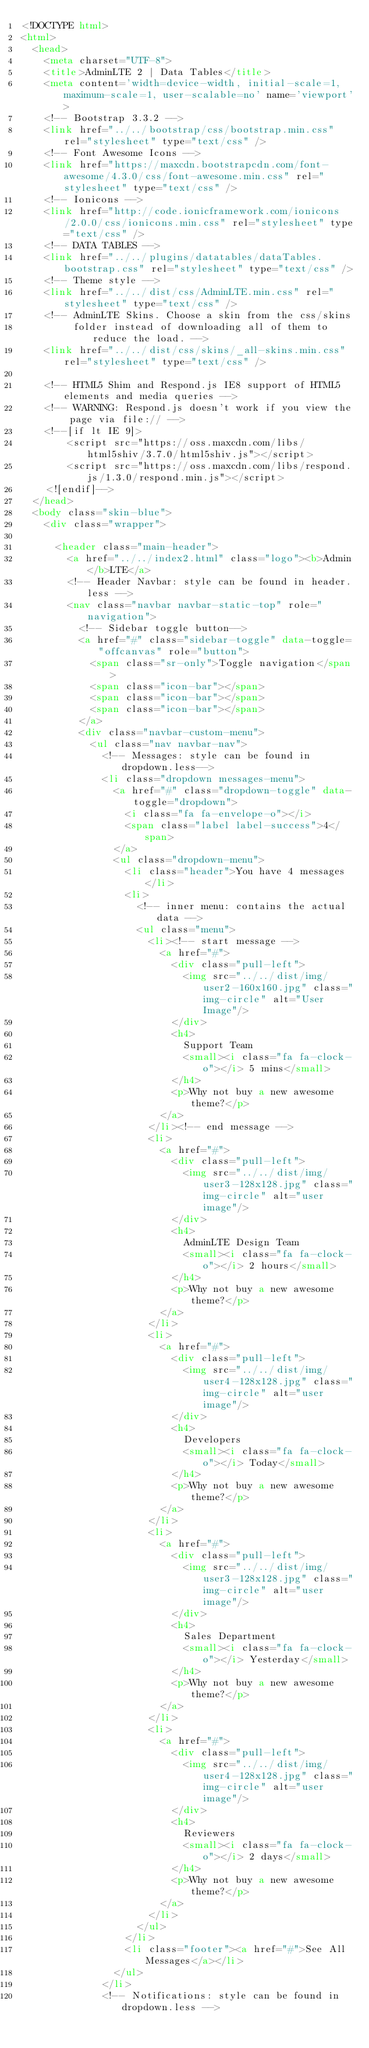Convert code to text. <code><loc_0><loc_0><loc_500><loc_500><_HTML_><!DOCTYPE html>
<html>
  <head>
    <meta charset="UTF-8">
    <title>AdminLTE 2 | Data Tables</title>
    <meta content='width=device-width, initial-scale=1, maximum-scale=1, user-scalable=no' name='viewport'>
    <!-- Bootstrap 3.3.2 -->
    <link href="../../bootstrap/css/bootstrap.min.css" rel="stylesheet" type="text/css" />
    <!-- Font Awesome Icons -->
    <link href="https://maxcdn.bootstrapcdn.com/font-awesome/4.3.0/css/font-awesome.min.css" rel="stylesheet" type="text/css" />
    <!-- Ionicons -->
    <link href="http://code.ionicframework.com/ionicons/2.0.0/css/ionicons.min.css" rel="stylesheet" type="text/css" />
    <!-- DATA TABLES -->
    <link href="../../plugins/datatables/dataTables.bootstrap.css" rel="stylesheet" type="text/css" />
    <!-- Theme style -->
    <link href="../../dist/css/AdminLTE.min.css" rel="stylesheet" type="text/css" />
    <!-- AdminLTE Skins. Choose a skin from the css/skins 
         folder instead of downloading all of them to reduce the load. -->
    <link href="../../dist/css/skins/_all-skins.min.css" rel="stylesheet" type="text/css" />

    <!-- HTML5 Shim and Respond.js IE8 support of HTML5 elements and media queries -->
    <!-- WARNING: Respond.js doesn't work if you view the page via file:// -->
    <!--[if lt IE 9]>
        <script src="https://oss.maxcdn.com/libs/html5shiv/3.7.0/html5shiv.js"></script>
        <script src="https://oss.maxcdn.com/libs/respond.js/1.3.0/respond.min.js"></script>
    <![endif]-->
  </head>
  <body class="skin-blue">
    <div class="wrapper">
      
      <header class="main-header">
        <a href="../../index2.html" class="logo"><b>Admin</b>LTE</a>
        <!-- Header Navbar: style can be found in header.less -->
        <nav class="navbar navbar-static-top" role="navigation">
          <!-- Sidebar toggle button-->
          <a href="#" class="sidebar-toggle" data-toggle="offcanvas" role="button">
            <span class="sr-only">Toggle navigation</span>
            <span class="icon-bar"></span>
            <span class="icon-bar"></span>
            <span class="icon-bar"></span>
          </a>
          <div class="navbar-custom-menu">
            <ul class="nav navbar-nav">
              <!-- Messages: style can be found in dropdown.less-->
              <li class="dropdown messages-menu">
                <a href="#" class="dropdown-toggle" data-toggle="dropdown">
                  <i class="fa fa-envelope-o"></i>
                  <span class="label label-success">4</span>
                </a>
                <ul class="dropdown-menu">
                  <li class="header">You have 4 messages</li>
                  <li>
                    <!-- inner menu: contains the actual data -->
                    <ul class="menu">
                      <li><!-- start message -->
                        <a href="#">
                          <div class="pull-left">
                            <img src="../../dist/img/user2-160x160.jpg" class="img-circle" alt="User Image"/>
                          </div>
                          <h4>
                            Support Team
                            <small><i class="fa fa-clock-o"></i> 5 mins</small>
                          </h4>
                          <p>Why not buy a new awesome theme?</p>
                        </a>
                      </li><!-- end message -->
                      <li>
                        <a href="#">
                          <div class="pull-left">
                            <img src="../../dist/img/user3-128x128.jpg" class="img-circle" alt="user image"/>
                          </div>
                          <h4>
                            AdminLTE Design Team
                            <small><i class="fa fa-clock-o"></i> 2 hours</small>
                          </h4>
                          <p>Why not buy a new awesome theme?</p>
                        </a>
                      </li>
                      <li>
                        <a href="#">
                          <div class="pull-left">
                            <img src="../../dist/img/user4-128x128.jpg" class="img-circle" alt="user image"/>
                          </div>
                          <h4>
                            Developers
                            <small><i class="fa fa-clock-o"></i> Today</small>
                          </h4>
                          <p>Why not buy a new awesome theme?</p>
                        </a>
                      </li>
                      <li>
                        <a href="#">
                          <div class="pull-left">
                            <img src="../../dist/img/user3-128x128.jpg" class="img-circle" alt="user image"/>
                          </div>
                          <h4>
                            Sales Department
                            <small><i class="fa fa-clock-o"></i> Yesterday</small>
                          </h4>
                          <p>Why not buy a new awesome theme?</p>
                        </a>
                      </li>
                      <li>
                        <a href="#">
                          <div class="pull-left">
                            <img src="../../dist/img/user4-128x128.jpg" class="img-circle" alt="user image"/>
                          </div>
                          <h4>
                            Reviewers
                            <small><i class="fa fa-clock-o"></i> 2 days</small>
                          </h4>
                          <p>Why not buy a new awesome theme?</p>
                        </a>
                      </li>
                    </ul>
                  </li>
                  <li class="footer"><a href="#">See All Messages</a></li>
                </ul>
              </li>
              <!-- Notifications: style can be found in dropdown.less --></code> 